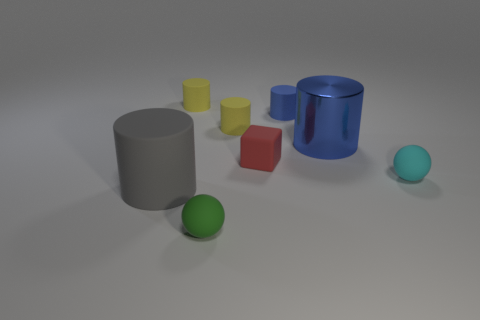Is the number of small objects that are on the right side of the cyan matte thing less than the number of red matte things?
Offer a terse response. Yes. Are there any tiny cyan matte objects on the right side of the red matte cube?
Offer a very short reply. Yes. Is there a large metal object of the same shape as the small cyan object?
Your answer should be compact. No. There is a cyan matte object that is the same size as the cube; what is its shape?
Give a very brief answer. Sphere. How many objects are either tiny spheres that are on the left side of the shiny cylinder or small rubber things?
Your response must be concise. 6. What is the size of the cylinder that is in front of the cyan matte sphere?
Make the answer very short. Large. Is there a gray cylinder that has the same size as the blue shiny cylinder?
Offer a terse response. Yes. Do the blue cylinder that is to the left of the metallic cylinder and the large rubber cylinder have the same size?
Your answer should be very brief. No. The green matte thing has what size?
Your response must be concise. Small. There is a sphere left of the large cylinder that is right of the tiny matte cylinder in front of the tiny blue matte object; what color is it?
Give a very brief answer. Green. 